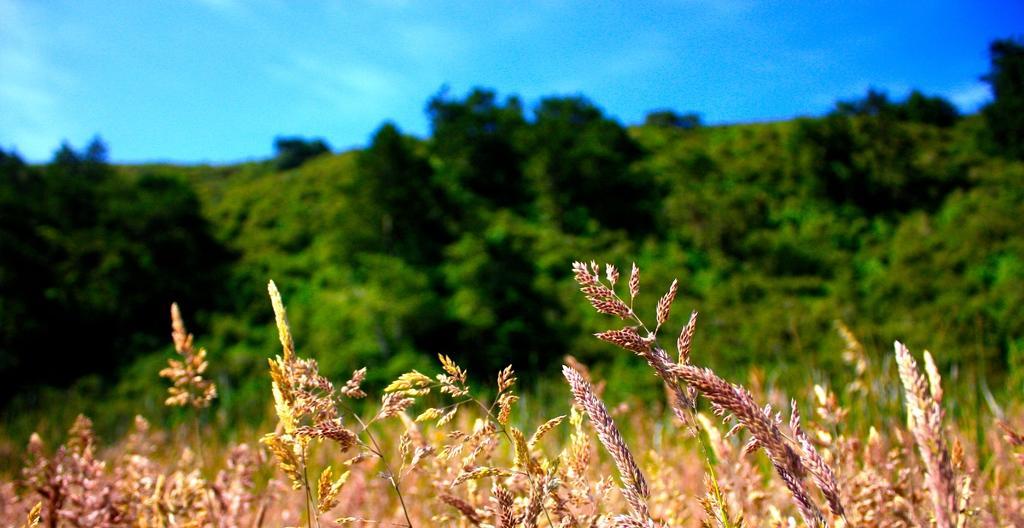Could you give a brief overview of what you see in this image? There are few plants and the background of the plants has a lot of greenery. 